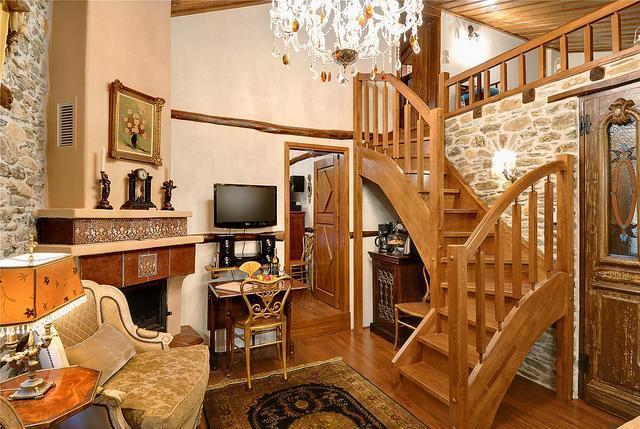How many spindles are in the staircase?
Give a very brief answer. 11. How many chairs are in the picture?
Give a very brief answer. 2. How many women are in the picture?
Give a very brief answer. 0. 